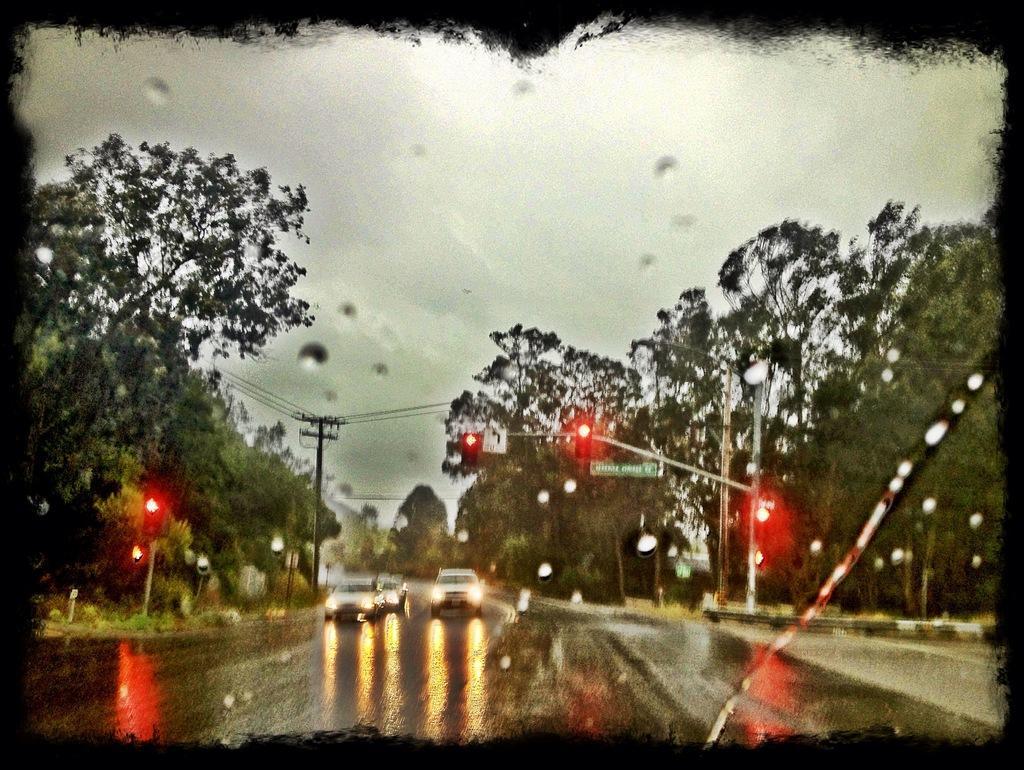Please provide a concise description of this image. In this image we can see some cars on the road, trees, traffic lights, utility pole with wires, board and the sky which looks cloudy. 